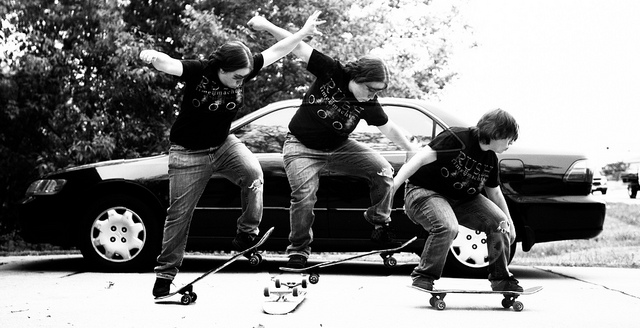Identify the text contained in this image. RUSH 